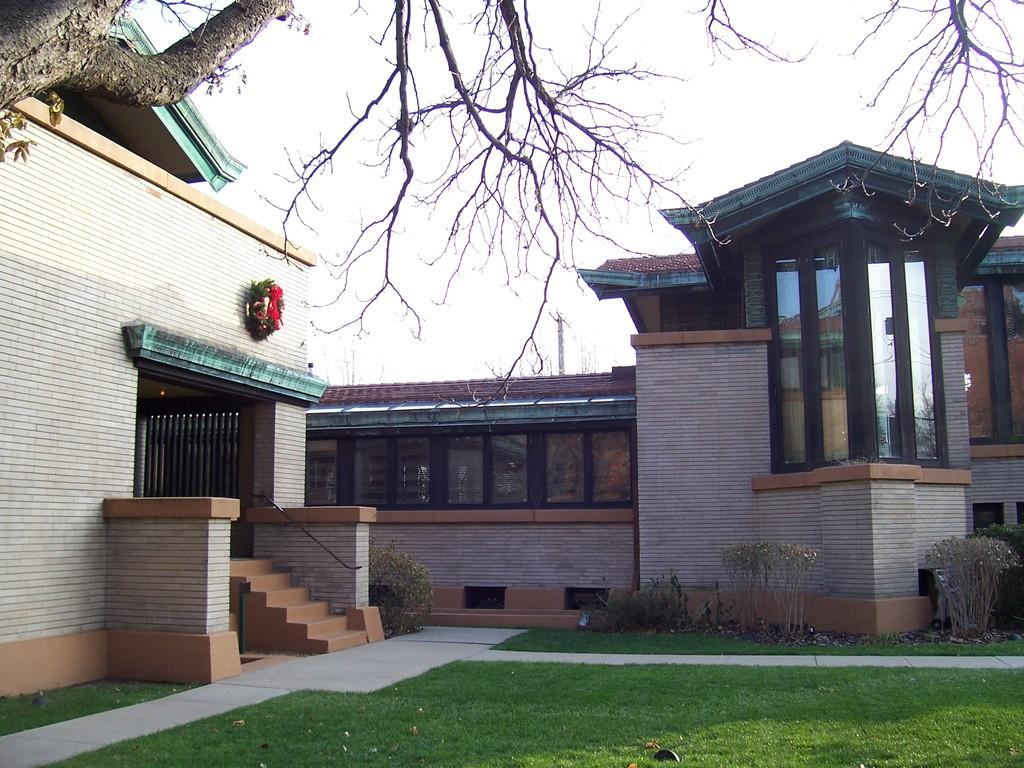What type of outdoor space is visible in the image? There is a lawn in the image. What other natural elements can be seen in the image? There are plants and a tree in the image. What type of structure is present in the image? There is a house in the image. What decorative item is visible in the image? There is a garland in the image. What can be seen in the background of the image? The sky is visible in the background of the image. What route does the car take to reach the house in the image? There is no car present in the image, so it is not possible to determine a route to the house. 